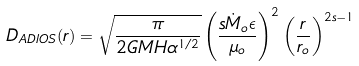Convert formula to latex. <formula><loc_0><loc_0><loc_500><loc_500>D _ { A D I O S } ( r ) = \sqrt { \frac { \pi } { 2 G M H \alpha ^ { 1 / 2 } } } \left ( \frac { s \dot { M } _ { o } \epsilon } { \mu _ { o } } \right ) ^ { 2 } \left ( \frac { r } { r _ { o } } \right ) ^ { 2 s - 1 }</formula> 